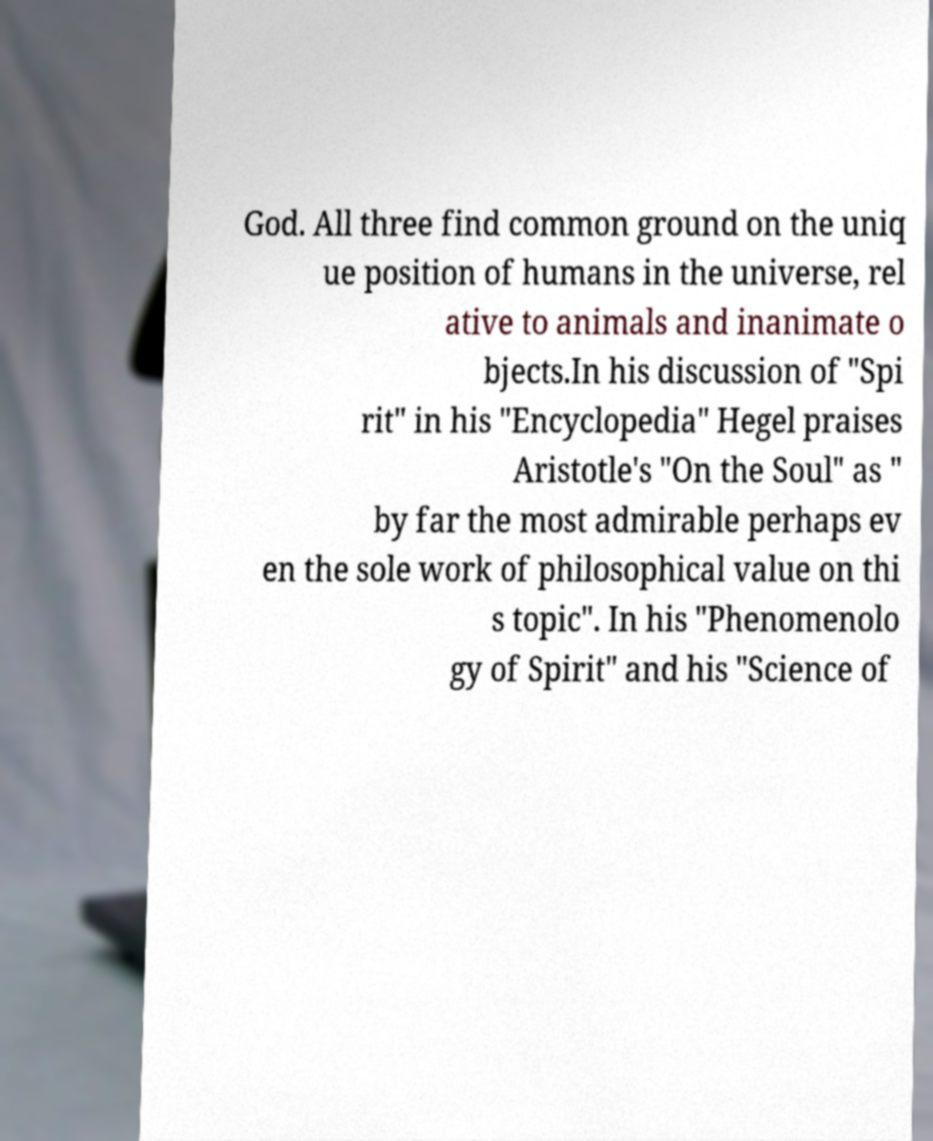Can you accurately transcribe the text from the provided image for me? God. All three find common ground on the uniq ue position of humans in the universe, rel ative to animals and inanimate o bjects.In his discussion of "Spi rit" in his "Encyclopedia" Hegel praises Aristotle's "On the Soul" as " by far the most admirable perhaps ev en the sole work of philosophical value on thi s topic". In his "Phenomenolo gy of Spirit" and his "Science of 